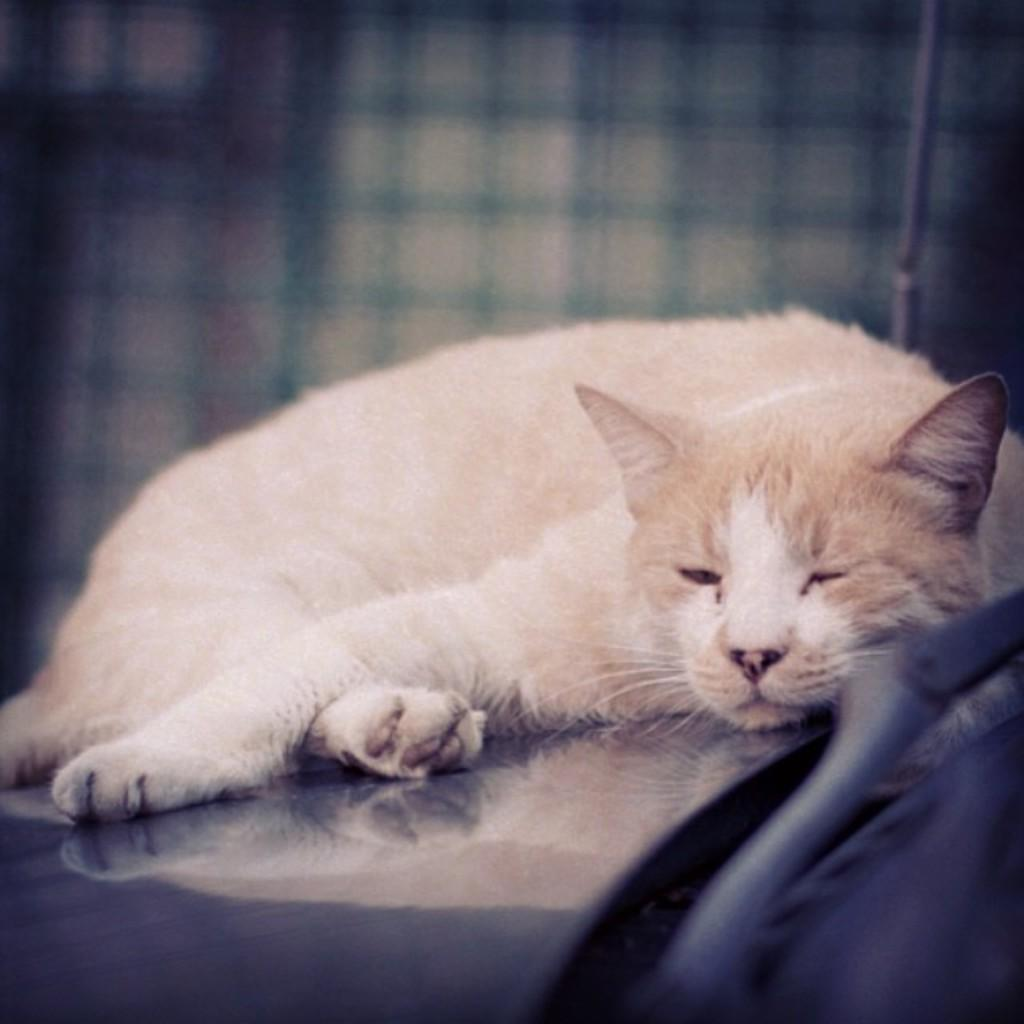What type of animal is in the image? There is a cat in the image. Can you describe the color of the cat? The cat is cream and white in color. How would you describe the quality of the image's background? The image is blurry in the background. What type of trousers is the cat wearing in the image? Cats do not wear trousers, so this detail cannot be found in the image. 